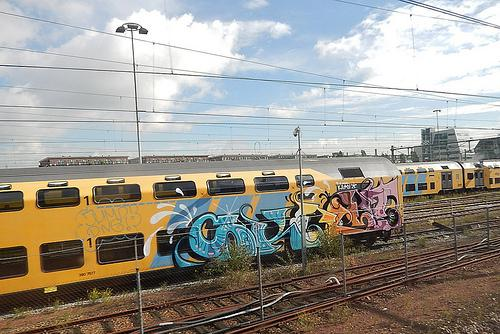Question: where is this scene?
Choices:
A. Ski lodge.
B. Home.
C. At the beach.
D. Railway.
Answer with the letter. Answer: D Question: what are in the sky?
Choices:
A. Sun.
B. Moon.
C. Clouds.
D. Stars.
Answer with the letter. Answer: C 